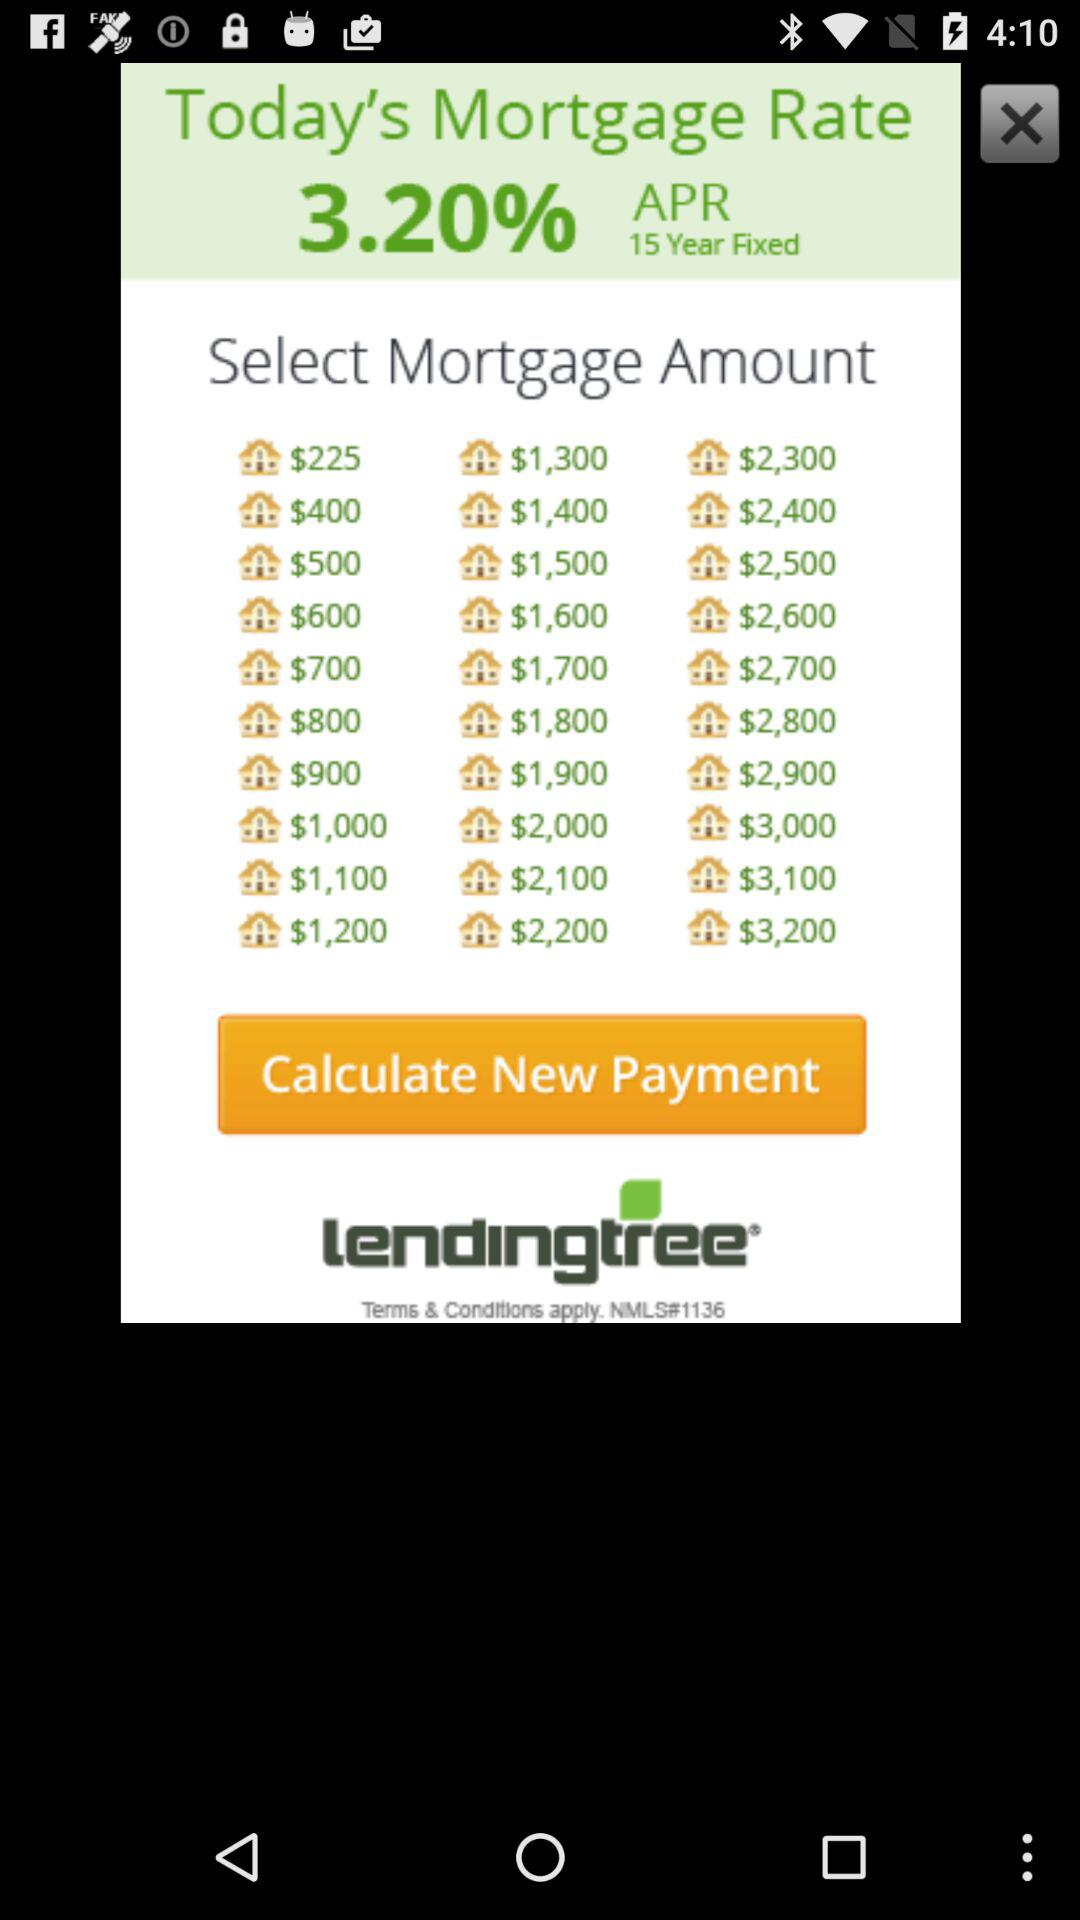What is today's mortgage rate? Today's mortgage rate is 3.20%. 